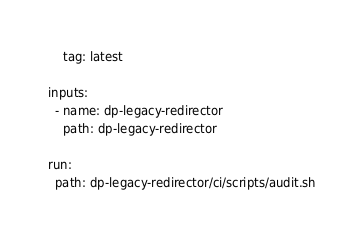Convert code to text. <code><loc_0><loc_0><loc_500><loc_500><_YAML_>    tag: latest

inputs:
  - name: dp-legacy-redirector
    path: dp-legacy-redirector

run:
  path: dp-legacy-redirector/ci/scripts/audit.sh
</code> 